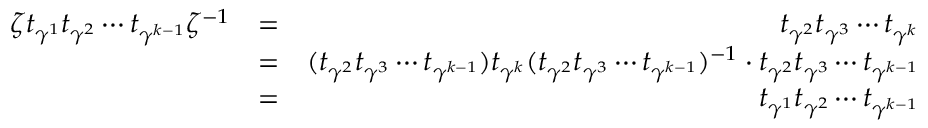Convert formula to latex. <formula><loc_0><loc_0><loc_500><loc_500>\begin{array} { r l r } { \zeta t _ { \gamma ^ { 1 } } t _ { \gamma ^ { 2 } } \cdots t _ { \gamma ^ { k - 1 } } \zeta ^ { - 1 } } & { = } & { t _ { \gamma ^ { 2 } } t _ { \gamma ^ { 3 } } \cdots t _ { \gamma ^ { k } } } \\ & { = } & { ( t _ { \gamma ^ { 2 } } t _ { \gamma ^ { 3 } } \cdots t _ { \gamma ^ { k - 1 } } ) t _ { \gamma ^ { k } } ( t _ { \gamma ^ { 2 } } t _ { \gamma ^ { 3 } } \cdots t _ { \gamma ^ { k - 1 } } ) ^ { - 1 } \cdot t _ { \gamma ^ { 2 } } t _ { \gamma ^ { 3 } } \cdots t _ { \gamma ^ { k - 1 } } } \\ & { = } & { t _ { \gamma ^ { 1 } } t _ { \gamma ^ { 2 } } \cdots t _ { \gamma ^ { k - 1 } } } \end{array}</formula> 